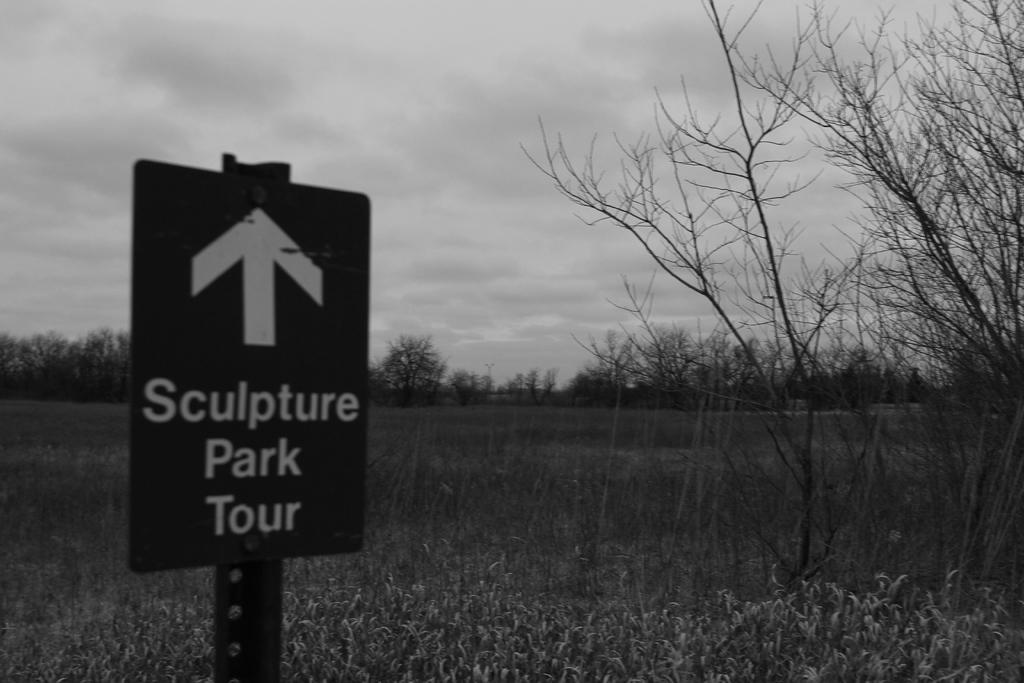What is the color scheme of the image? The image is black and white. What can be seen on the sign board in the image? The content of the sign board is not mentioned, but we know that there is a sign board in the image. What type of vegetation is present in the image? There are plants and trees in the image. What is visible in the background of the image? The sky is visible in the image, and there are clouds present in the sky. What grade is the kite flying in the image? There is no kite present in the image, so it is not possible to determine the grade it might be flying in. What type of journey is depicted in the image? The image does not depict a journey; it features a sign board, plants, trees, and a sky with clouds. 